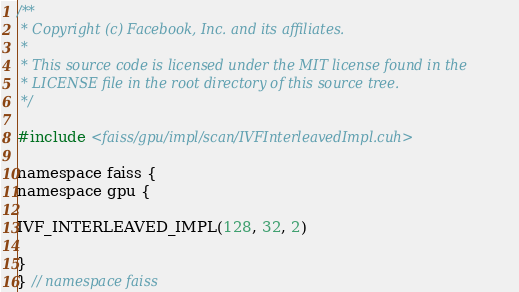<code> <loc_0><loc_0><loc_500><loc_500><_Cuda_>/**
 * Copyright (c) Facebook, Inc. and its affiliates.
 *
 * This source code is licensed under the MIT license found in the
 * LICENSE file in the root directory of this source tree.
 */

#include <faiss/gpu/impl/scan/IVFInterleavedImpl.cuh>

namespace faiss {
namespace gpu {

IVF_INTERLEAVED_IMPL(128, 32, 2)

}
} // namespace faiss
</code> 